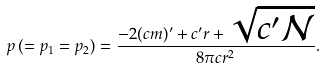<formula> <loc_0><loc_0><loc_500><loc_500>p \, ( = p _ { 1 } = p _ { 2 } ) = { \frac { - 2 ( c m ) ^ { \prime } + c ^ { \prime } r + \sqrt { c ^ { \prime } \mathcal { N } } } { 8 \pi c r ^ { 2 } } } .</formula> 